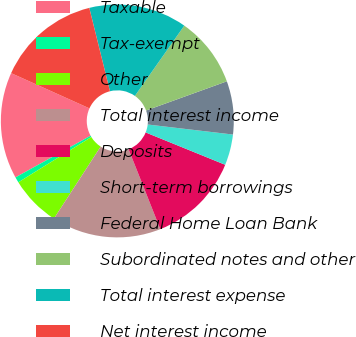Convert chart. <chart><loc_0><loc_0><loc_500><loc_500><pie_chart><fcel>Taxable<fcel>Tax-exempt<fcel>Other<fcel>Total interest income<fcel>Deposits<fcel>Short-term borrowings<fcel>Federal Home Loan Bank<fcel>Subordinated notes and other<fcel>Total interest expense<fcel>Net interest income<nl><fcel>14.79%<fcel>0.78%<fcel>7.0%<fcel>15.18%<fcel>12.84%<fcel>4.28%<fcel>7.39%<fcel>9.73%<fcel>13.62%<fcel>14.4%<nl></chart> 